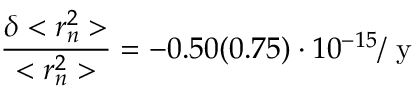Convert formula to latex. <formula><loc_0><loc_0><loc_500><loc_500>\frac { \delta < r _ { n } ^ { 2 } > } { < r _ { n } ^ { 2 } > } = - 0 . 5 0 ( 0 . 7 5 ) \cdot 1 0 ^ { - 1 5 } / y</formula> 